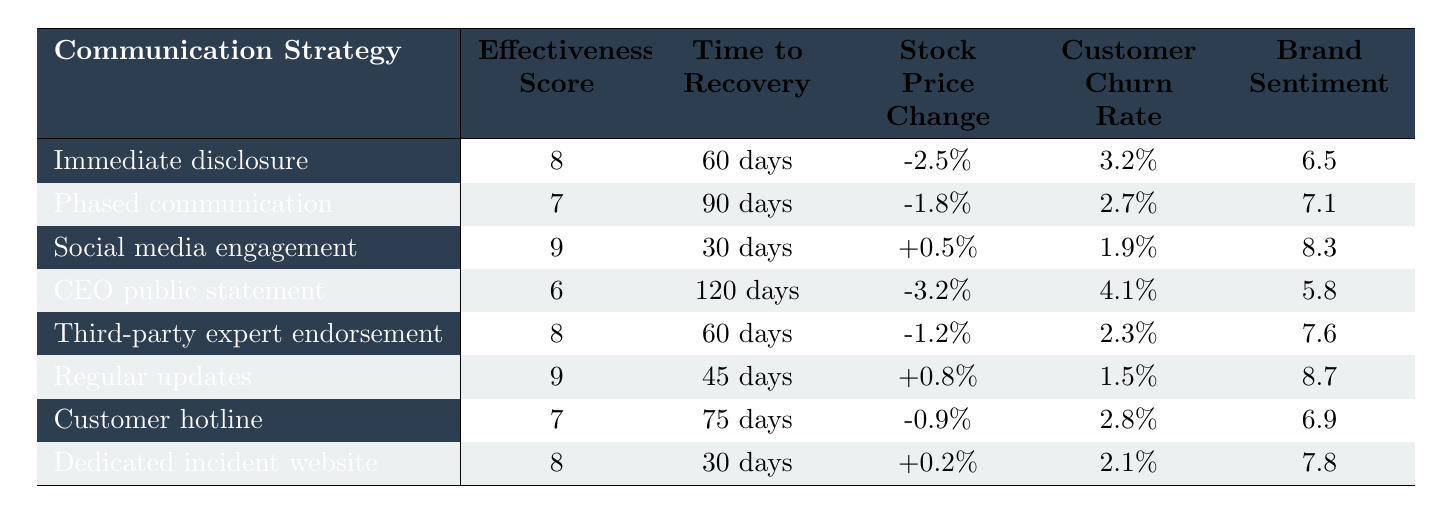What is the effectiveness score for immediate disclosure? The table lists "Immediate disclosure" with an effectiveness score of 8 in the corresponding column.
Answer: 8 Which communication strategy resulted in the highest brand sentiment score? By comparing the brand sentiment scores, "Regular updates" has the highest score of 8.7.
Answer: Regular updates What is the average time to recovery for all listed communication strategies? The times to recovery (in days) are 60, 90, 30, 120, 60, 45, 75, and 30. The sum is 60 + 90 + 30 + 120 + 60 + 45 + 75 + 30 = 510. There are 8 strategies, so the average is 510/8 = 63.75 days.
Answer: 63.75 days Did any communication strategies show a positive stock price change? Yes, the table indicates that "Social media engagement" and "Regular updates" had positive stock price changes of +0.5% and +0.8%, respectively.
Answer: Yes Is there a communication strategy that leads to lower customer churn compared to immediate disclosure? Immediate disclosure has a customer churn rate of 3.2%. "Social media engagement" has a lower churn rate of 1.9%, thus indicating that it leads to lower churn.
Answer: Yes Which communication strategy has the highest effectiveness score combined with the shortest recovery time? Evaluating effectiveness scores along with recovery times, "Social media engagement" has the highest score of 9 and a recovery time of 30 days, which is the shortest.
Answer: Social media engagement How does the effectiveness of third-party expert endorsement compare to the phased communication strategy? "Third-party expert endorsement" has an effectiveness score of 8, while "Phased communication" has a score of 7. Therefore, third-party expert endorsement is more effective.
Answer: Third-party expert endorsement is more effective What is the relationship between effectiveness scores and brand sentiment scores? By observation, as the effectiveness scores rise (from 6 to 9), brand sentiment scores also increase, indicating a positive correlation between the two metrics.
Answer: Positive correlation Which communication strategy has the longest time to recovery and what is that duration? The "CEO public statement" strategy has the longest time to recovery at 120 days, as noted in the table.
Answer: 120 days Is there a communication strategy with a negative stock price change that also has a high effectiveness score? Yes, "CEO public statement" has an effectiveness score of 6 and a negative stock price change of -3.2%.
Answer: Yes 